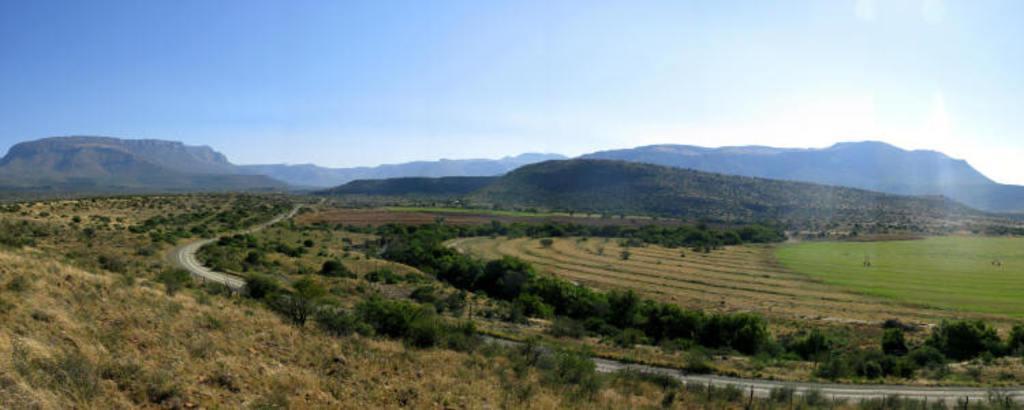How would you summarize this image in a sentence or two? In this image there are trees and we can see a road. In the background there are hills and sky. 